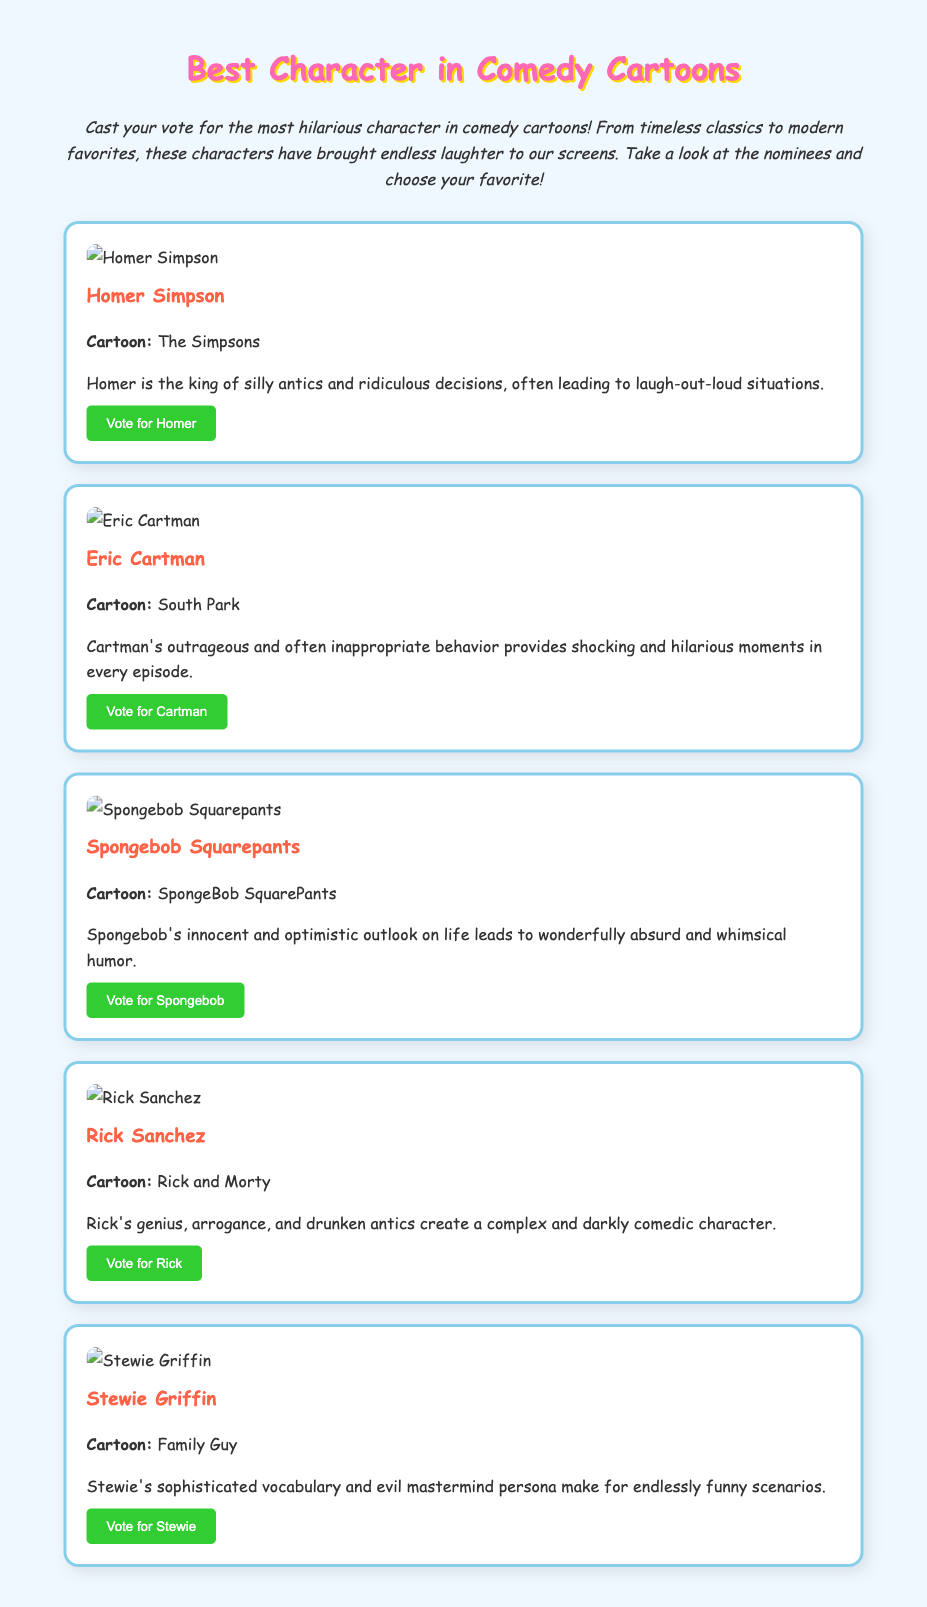What is the title of the ballot? The title of the ballot, displayed at the top of the document, identifies the main focus of the voting event.
Answer: Best Character in Comedy Cartoons Who is the first nominee listed? The first nominee presented in the document is listed within a section dedicated to nominees, showcasing their images and descriptions.
Answer: Homer Simpson What cartoon is Eric Cartman from? The document clearly indicates the cartoon associated with Eric Cartman in a specified section under his name.
Answer: South Park Which character is described as having "sophisticated vocabulary"? The description for Stewie Griffin highlights his intelligent speech, which is a key aspect of his characterization.
Answer: Stewie Griffin How many nominees are presented in the ballot? The total count of nominees can be determined by counting the individual sections for each character in the document.
Answer: Five 